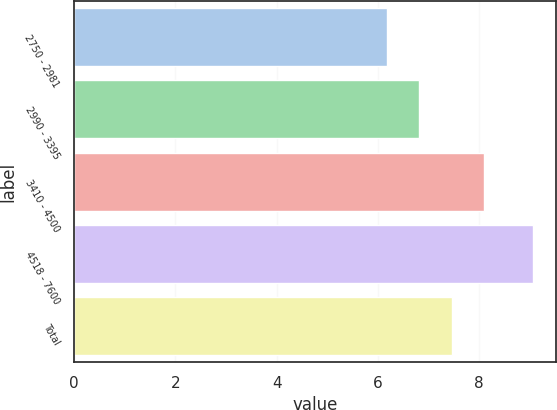Convert chart to OTSL. <chart><loc_0><loc_0><loc_500><loc_500><bar_chart><fcel>2750 - 2981<fcel>2990 - 3395<fcel>3410 - 4500<fcel>4518 - 7600<fcel>Total<nl><fcel>6.18<fcel>6.82<fcel>8.09<fcel>9.06<fcel>7.46<nl></chart> 